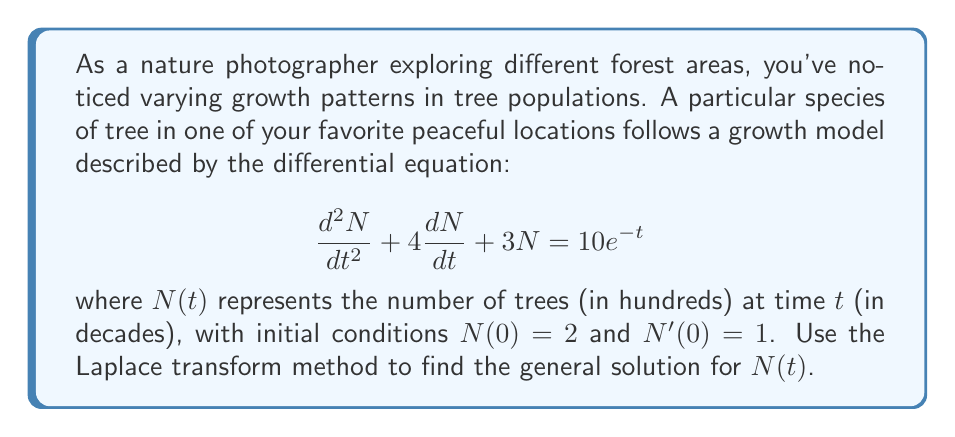Provide a solution to this math problem. Let's solve this problem step by step using the Laplace transform method:

1) First, let's take the Laplace transform of both sides of the equation. Let $\mathcal{L}\{N(t)\} = X(s)$.

   $$\mathcal{L}\{\frac{d^2N}{dt^2} + 4\frac{dN}{dt} + 3N\} = \mathcal{L}\{10e^{-t}\}$$

2) Using Laplace transform properties:

   $$s^2X(s) - sN(0) - N'(0) + 4[sX(s) - N(0)] + 3X(s) = \frac{10}{s+1}$$

3) Substituting the initial conditions $N(0) = 2$ and $N'(0) = 1$:

   $$s^2X(s) - 2s - 1 + 4sX(s) - 8 + 3X(s) = \frac{10}{s+1}$$

4) Simplifying:

   $$(s^2 + 4s + 3)X(s) = \frac{10}{s+1} + 2s + 9$$

5) Solving for $X(s)$:

   $$X(s) = \frac{10}{(s+1)(s^2 + 4s + 3)} + \frac{2s + 9}{s^2 + 4s + 3}$$

6) The denominator $s^2 + 4s + 3$ can be factored as $(s+1)(s+3)$. Using partial fraction decomposition:

   $$X(s) = \frac{A}{s+1} + \frac{B}{s+3} + \frac{10}{(s+1)^2} + \frac{C}{s+1} + \frac{D}{s+3}$$

7) Solving for the constants $A$, $B$, $C$, and $D$:

   $$X(s) = \frac{5}{(s+1)^2} + \frac{5}{(s+1)} - \frac{5}{(s+3)}$$

8) Taking the inverse Laplace transform:

   $$N(t) = 5te^{-t} + 5e^{-t} - 5e^{-3t}$$

This is the general solution for $N(t)$.
Answer: $N(t) = 5te^{-t} + 5e^{-t} - 5e^{-3t}$ 